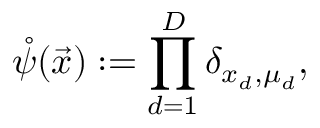<formula> <loc_0><loc_0><loc_500><loc_500>\mathring { \psi } ( \vec { x } ) \colon = \prod _ { d = 1 } ^ { D } \delta _ { x _ { d } , \mu _ { d } } ,</formula> 